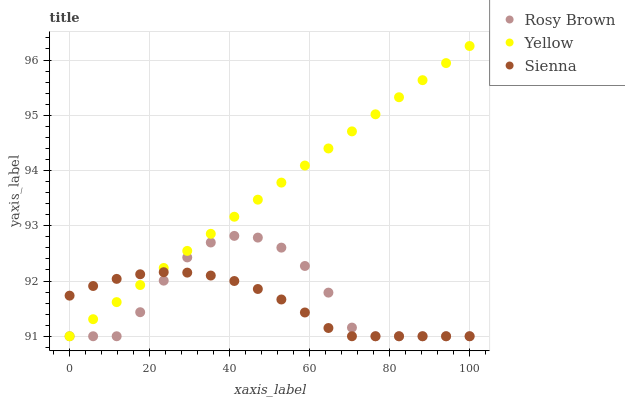Does Sienna have the minimum area under the curve?
Answer yes or no. Yes. Does Yellow have the maximum area under the curve?
Answer yes or no. Yes. Does Rosy Brown have the minimum area under the curve?
Answer yes or no. No. Does Rosy Brown have the maximum area under the curve?
Answer yes or no. No. Is Yellow the smoothest?
Answer yes or no. Yes. Is Rosy Brown the roughest?
Answer yes or no. Yes. Is Rosy Brown the smoothest?
Answer yes or no. No. Is Yellow the roughest?
Answer yes or no. No. Does Sienna have the lowest value?
Answer yes or no. Yes. Does Yellow have the highest value?
Answer yes or no. Yes. Does Rosy Brown have the highest value?
Answer yes or no. No. Does Yellow intersect Rosy Brown?
Answer yes or no. Yes. Is Yellow less than Rosy Brown?
Answer yes or no. No. Is Yellow greater than Rosy Brown?
Answer yes or no. No. 